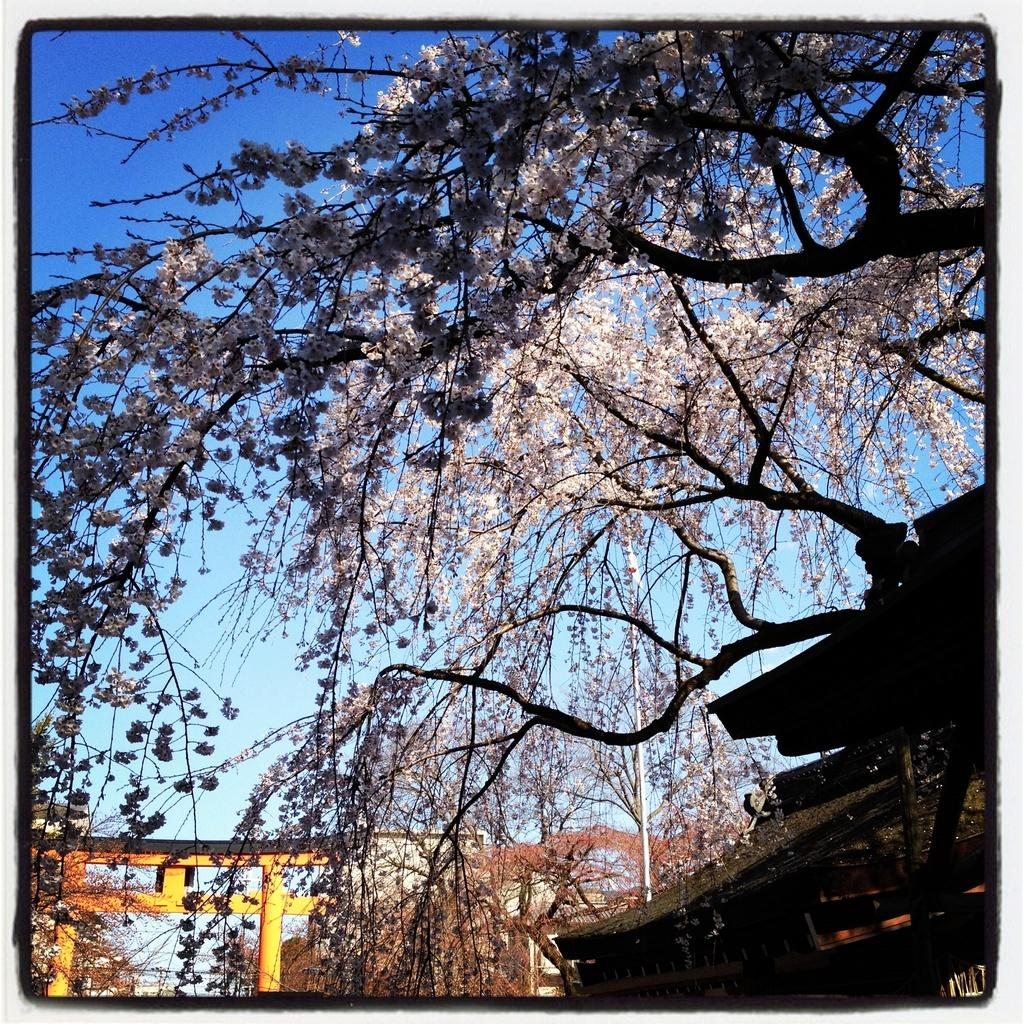What type of vegetation can be seen in the image? There are trees in the image. What structure is present in the image? There is a pole in the image. What type of man-made structures are visible in the image? There are buildings in the image. What is visible in the background of the image? The sky is visible in the background of the image. Where is the nearest hydrant to the buildings in the image? There is no hydrant present in the image, so it cannot be determined. What type of books can be found in the library depicted in the image? There is no library present in the image, so it cannot be determined. 